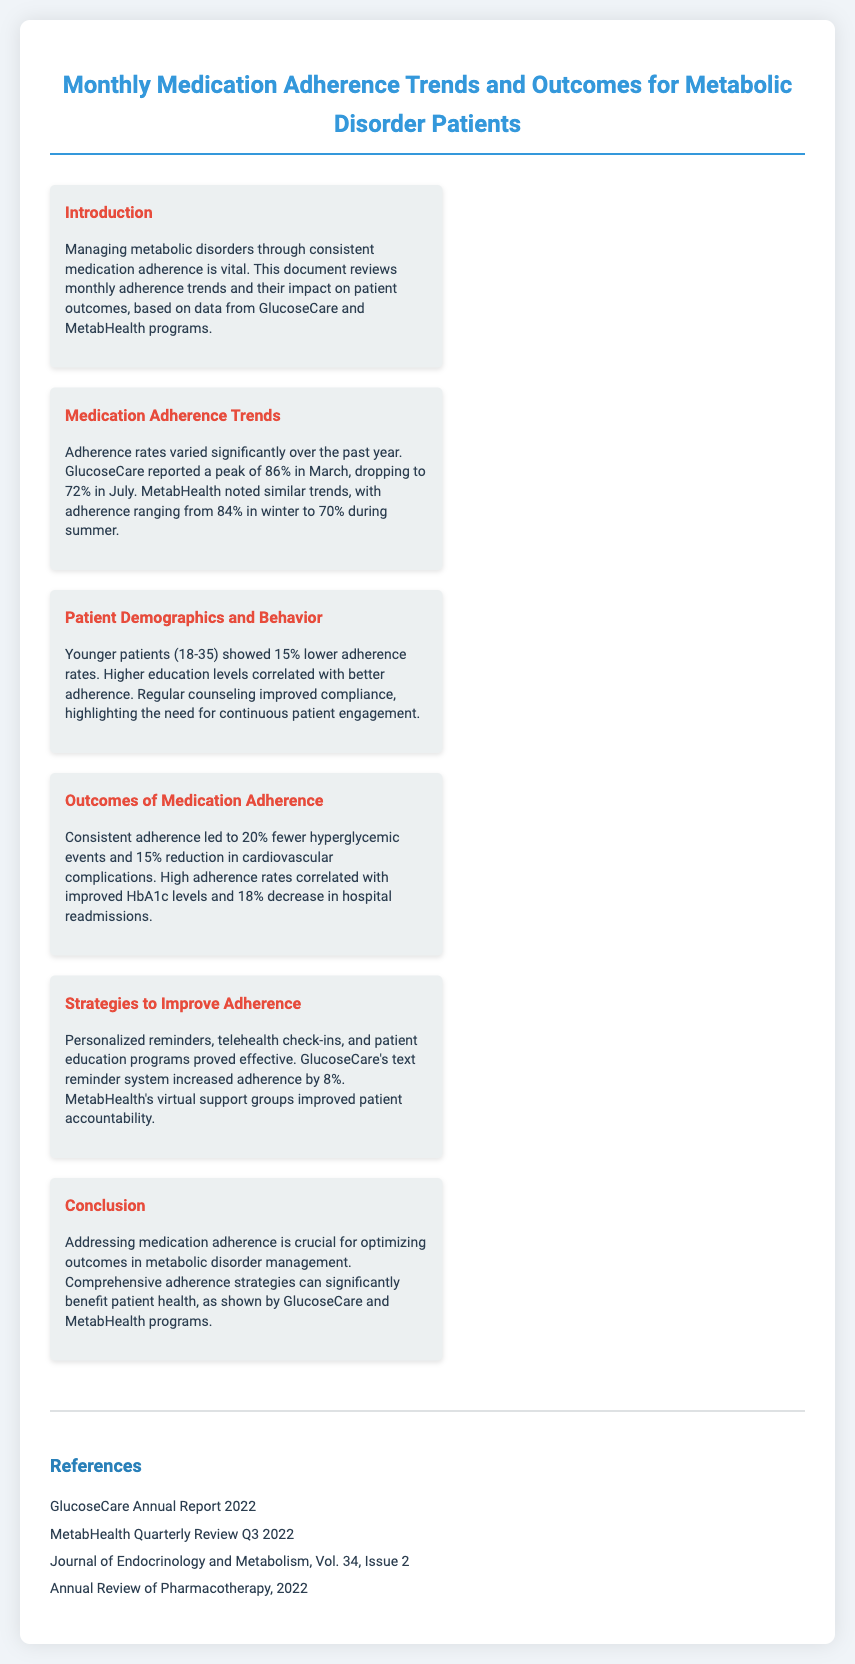what was the peak adherence rate reported by GlucoseCare? The peak adherence rate reported by GlucoseCare is mentioned in the "Medication Adherence Trends" section, which states it peaked at 86% in March.
Answer: 86% what percentage did adherence drop to in July for GlucoseCare? The adherence drop to 72% in July for GlucoseCare is specified in the "Medication Adherence Trends" section.
Answer: 72% how much did hyperglycemic events decrease with consistent adherence? The decrease in hyperglycemic events with consistent adherence is highlighted in the "Outcomes of Medication Adherence" section, which states it led to 20% fewer hyperglycemic events.
Answer: 20% what educational correlation exists with adherence rates? The document notes that higher education levels correlated with better adherence in the "Patient Demographics and Behavior" section.
Answer: Higher education levels which strategy improved adherence by 8% according to GlucoseCare? The "Strategies to Improve Adherence" section mentions that GlucoseCare's text reminder system increased adherence by 8%.
Answer: Text reminder system how many references are listed at the end of the document? The number of references can be counted from the "References" section, where four sources are listed.
Answer: Four what is the main conclusion drawn in the document? The conclusion emphasizes the need for comprehensive adherence strategies to optimize outcomes, as stated in the "Conclusion" section.
Answer: Comprehensive adherence strategies which patient age group showed lower adherence rates? The "Patient Demographics and Behavior" section specifies that younger patients (18-35) showed 15% lower adherence rates.
Answer: 18-35 how much reduction in cardiovascular complications was noted? The reduction in cardiovascular complications due to consistent adherence is stated in the "Outcomes of Medication Adherence" section, indicating a 15% reduction.
Answer: 15% what type of programs proved effective in improving adherence? The "Strategies to Improve Adherence" section states that patient education programs proved effective for adherence improvement.
Answer: Patient education programs 